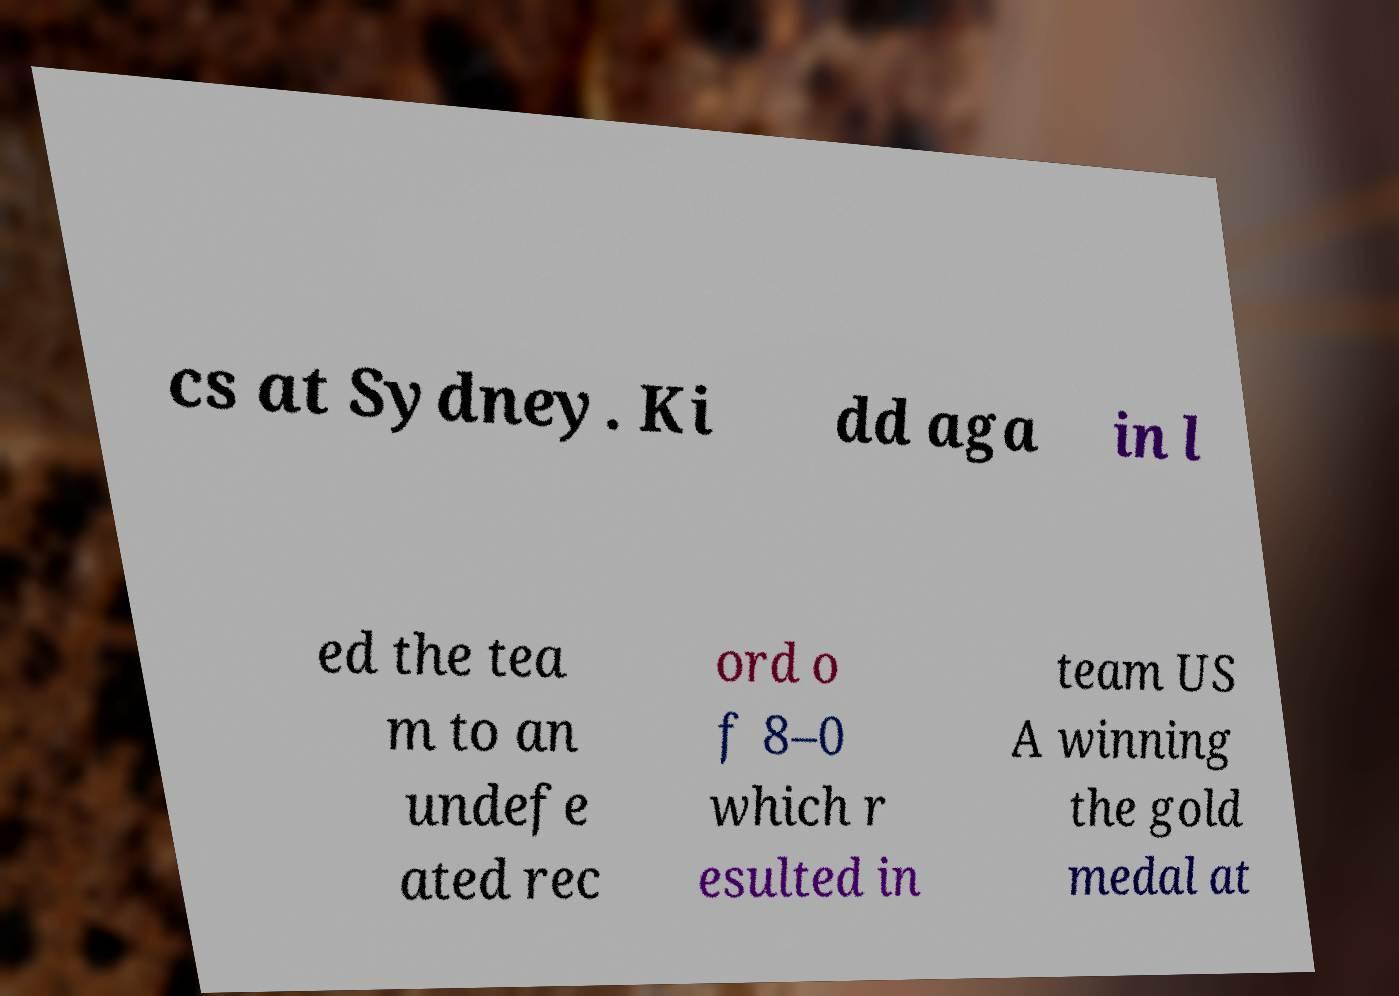Could you extract and type out the text from this image? cs at Sydney. Ki dd aga in l ed the tea m to an undefe ated rec ord o f 8–0 which r esulted in team US A winning the gold medal at 